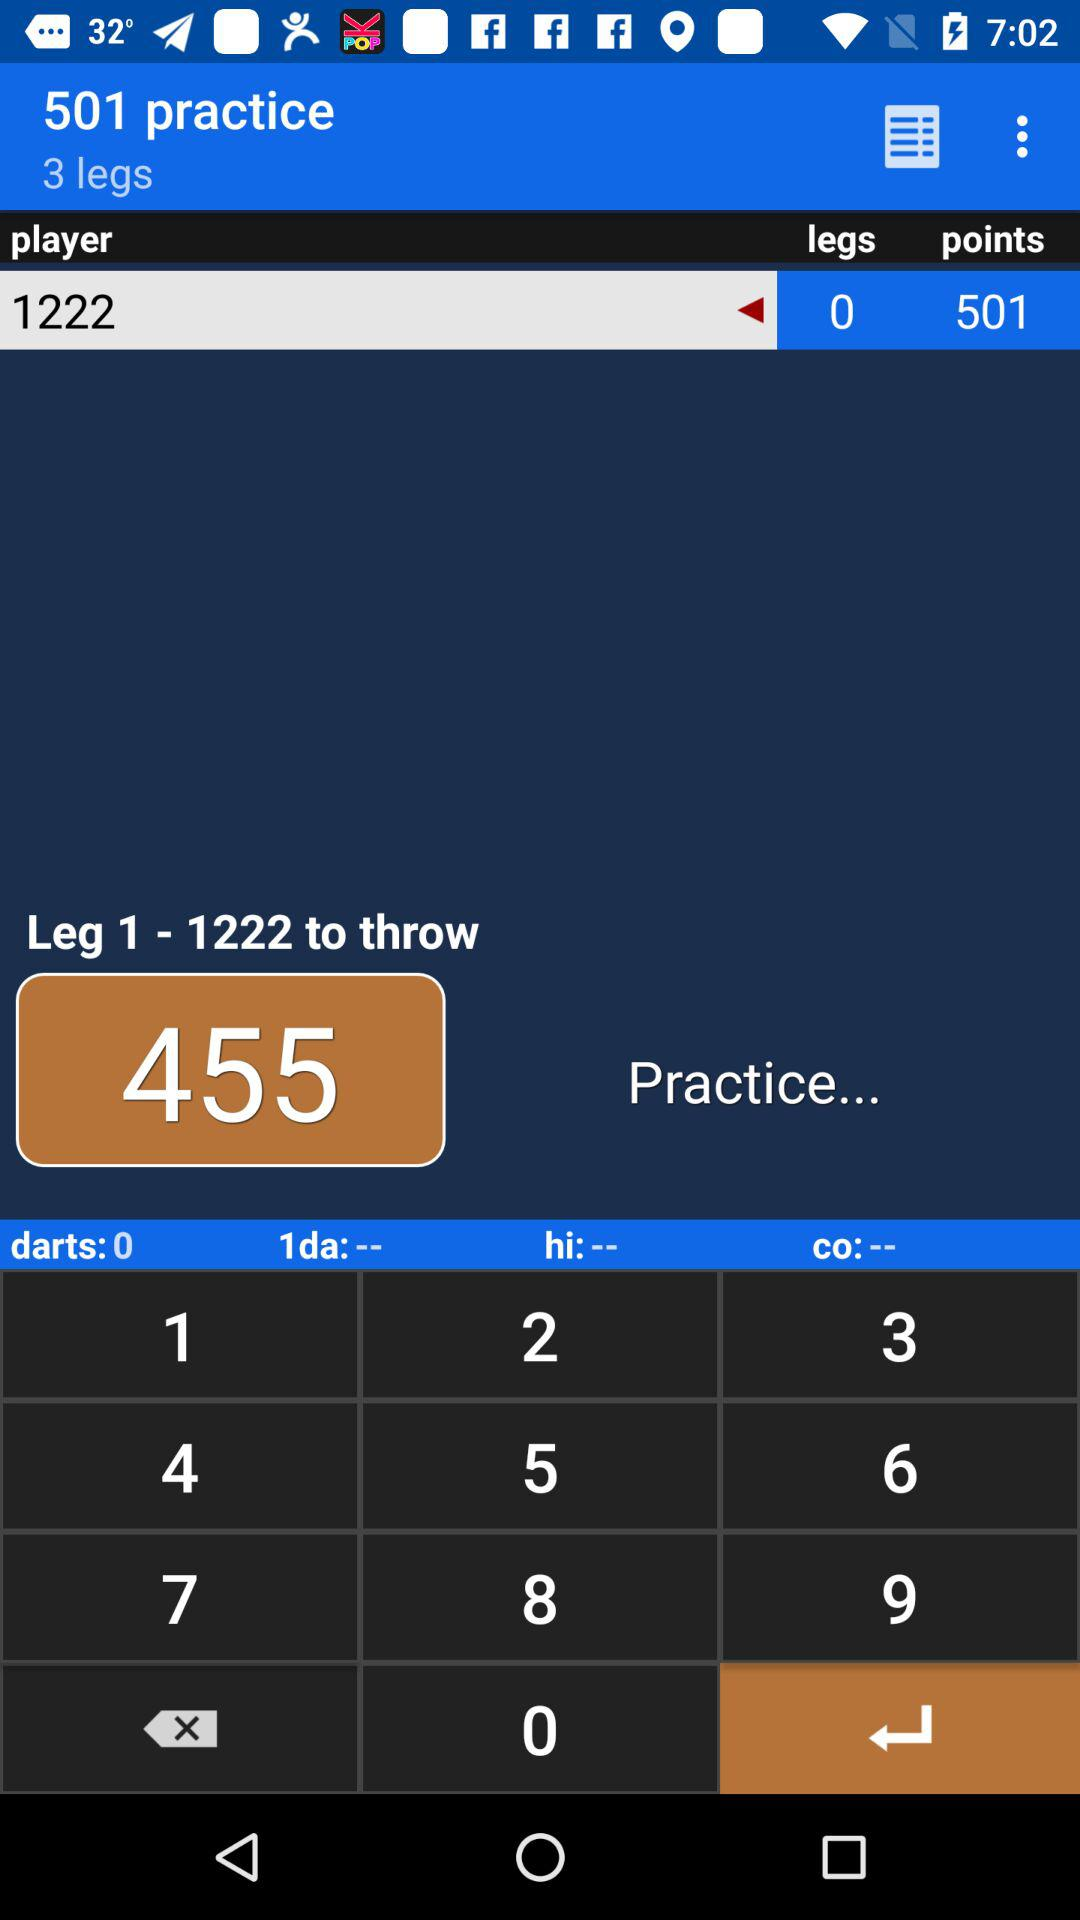What is the total quantity of practice? The total quantity is 501. 